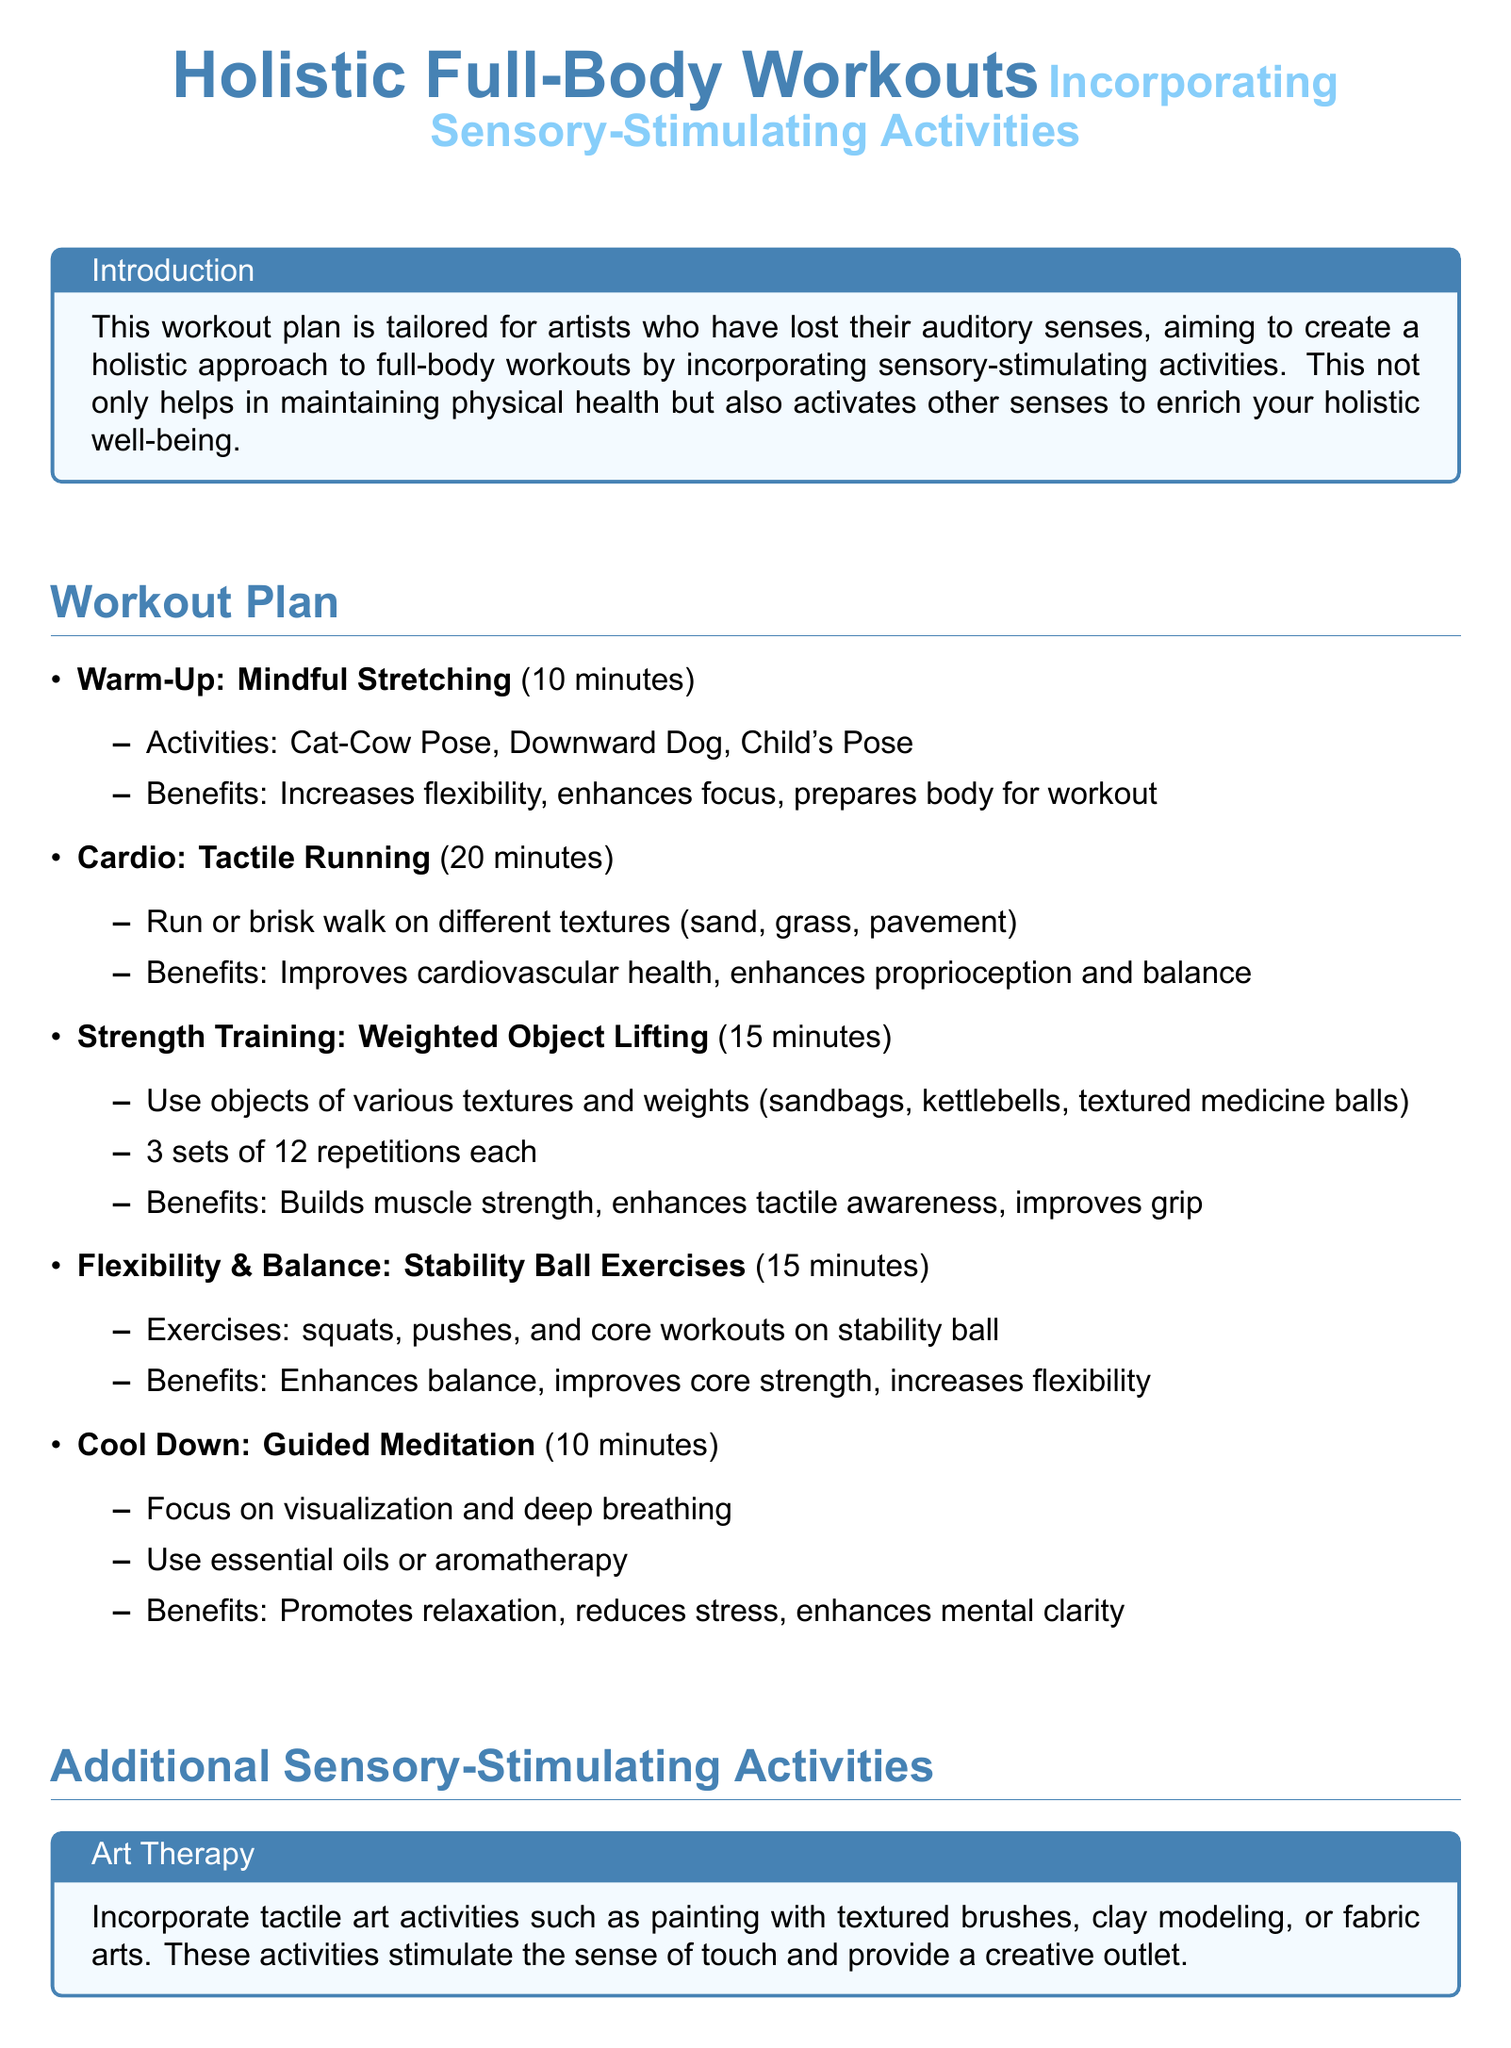What is the duration of the warm-up? The warm-up consists of mindful stretching activities that last for 10 minutes.
Answer: 10 minutes How many sets of strength training are recommended? The strength training section specifies to do 3 sets of 12 repetitions each.
Answer: 3 sets What type of meditation is suggested for cool down? The cool down section mentions guided meditation focusing on visualization and deep breathing.
Answer: Guided meditation What benefits are associated with tactile running? Tactile running improves cardiovascular health and enhances proprioception and balance.
Answer: Improves cardiovascular health, enhances proprioception and balance What is an example of a tactile art activity? The document mentions painting with textured brushes as a tactile art activity.
Answer: Painting with textured brushes What exercise is suggested for flexibility and balance? The plan recommends stability ball exercises for flexibility and balance.
Answer: Stability ball exercises What is the overall goal of the workout plan? The workout plan aims to create a holistic approach that maintains physical health and enriches holistic well-being.
Answer: Holistic approach to full-body workouts How long is the cardio portion of the workout? The cardio section describes a tactile running or brisk walking session lasting for 20 minutes.
Answer: 20 minutes 